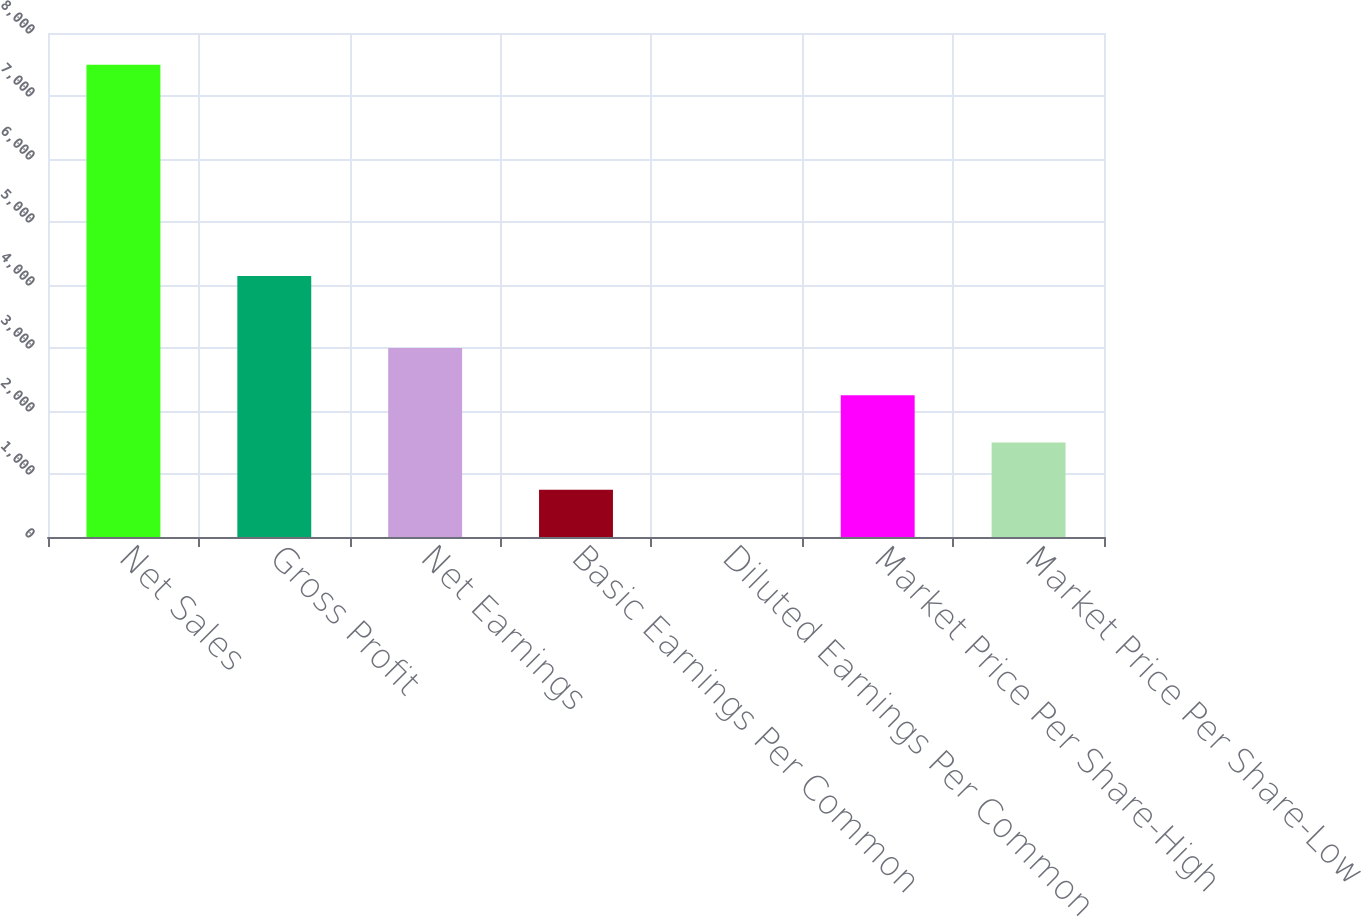<chart> <loc_0><loc_0><loc_500><loc_500><bar_chart><fcel>Net Sales<fcel>Gross Profit<fcel>Net Earnings<fcel>Basic Earnings Per Common<fcel>Diluted Earnings Per Common<fcel>Market Price Per Share-High<fcel>Market Price Per Share-Low<nl><fcel>7497.7<fcel>4144.8<fcel>2999.49<fcel>750.39<fcel>0.69<fcel>2249.79<fcel>1500.09<nl></chart> 